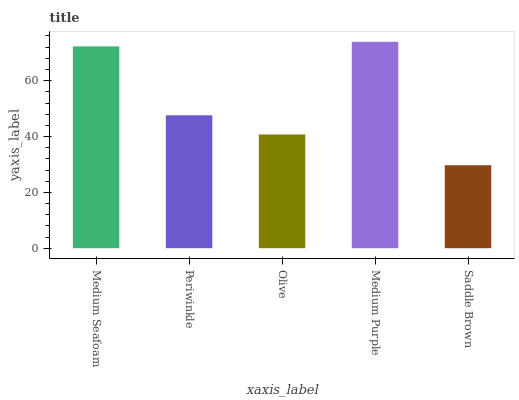Is Saddle Brown the minimum?
Answer yes or no. Yes. Is Medium Purple the maximum?
Answer yes or no. Yes. Is Periwinkle the minimum?
Answer yes or no. No. Is Periwinkle the maximum?
Answer yes or no. No. Is Medium Seafoam greater than Periwinkle?
Answer yes or no. Yes. Is Periwinkle less than Medium Seafoam?
Answer yes or no. Yes. Is Periwinkle greater than Medium Seafoam?
Answer yes or no. No. Is Medium Seafoam less than Periwinkle?
Answer yes or no. No. Is Periwinkle the high median?
Answer yes or no. Yes. Is Periwinkle the low median?
Answer yes or no. Yes. Is Medium Purple the high median?
Answer yes or no. No. Is Medium Purple the low median?
Answer yes or no. No. 